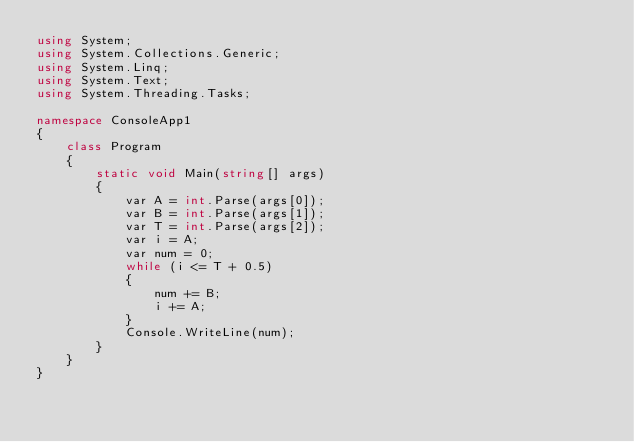Convert code to text. <code><loc_0><loc_0><loc_500><loc_500><_C#_>using System;
using System.Collections.Generic;
using System.Linq;
using System.Text;
using System.Threading.Tasks;

namespace ConsoleApp1
{
    class Program
    {
        static void Main(string[] args)
        {
            var A = int.Parse(args[0]);
            var B = int.Parse(args[1]);
            var T = int.Parse(args[2]);
            var i = A;
            var num = 0;
            while (i <= T + 0.5)
            {
                num += B; 
                i += A;
            }
            Console.WriteLine(num);
        }
    }
}</code> 